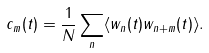<formula> <loc_0><loc_0><loc_500><loc_500>c _ { m } ( t ) = \frac { 1 } { N } \sum _ { n } \langle w _ { n } ( t ) w _ { n + m } ( t ) \rangle .</formula> 